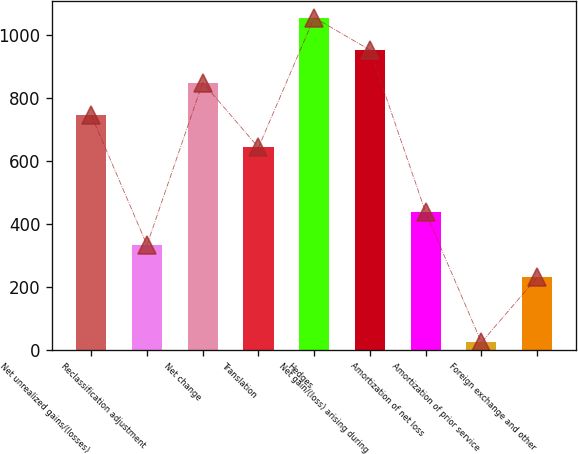<chart> <loc_0><loc_0><loc_500><loc_500><bar_chart><fcel>Net unrealized gains/(losses)<fcel>Reclassification adjustment<fcel>Net change<fcel>Translation<fcel>Hedges<fcel>Net gain/(loss) arising during<fcel>Amortization of net loss<fcel>Amortization of prior service<fcel>Foreign exchange and other<nl><fcel>746.1<fcel>332.9<fcel>849.4<fcel>642.8<fcel>1056<fcel>952.7<fcel>436.2<fcel>23<fcel>229.6<nl></chart> 